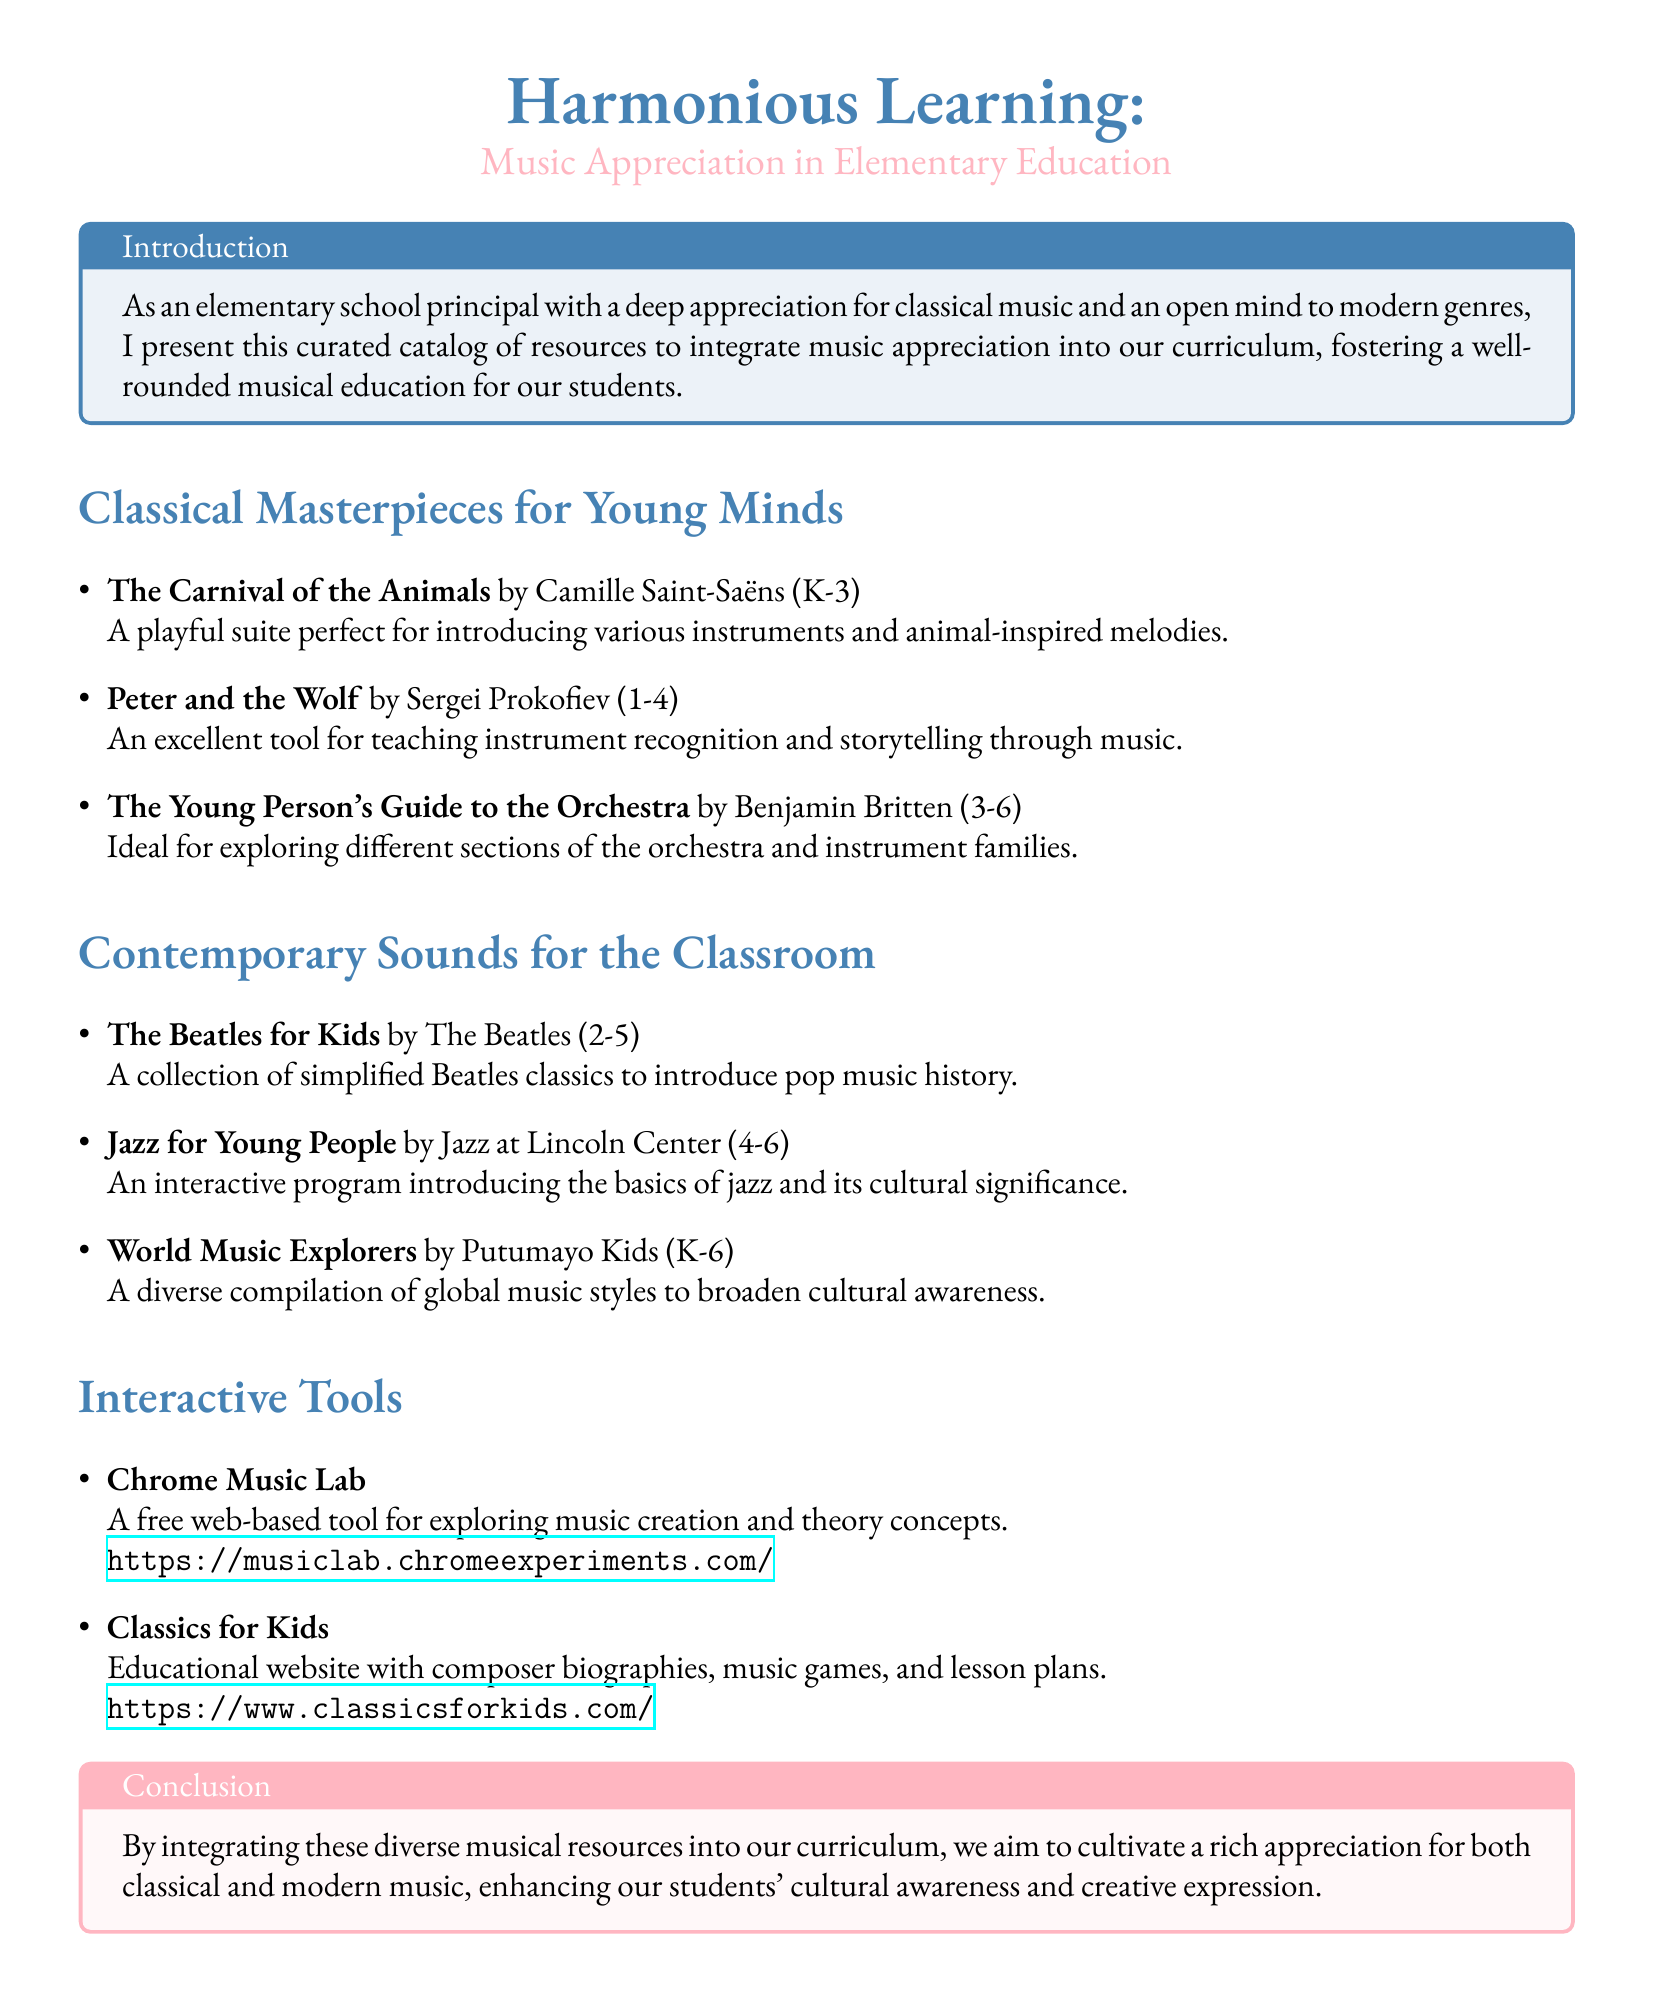What is the title of the catalog? The title of the catalog is prominently displayed at the top of the document, introducing the theme of music appreciation in education.
Answer: Harmonious Learning: Music Appreciation in Elementary Education Who composed "The Carnival of the Animals"? The composer of "The Carnival of the Animals" is mentioned in the section about classical masterpieces, indicating the artist behind the work.
Answer: Camille Saint-Saëns What grade levels does "Peter and the Wolf" target? The document specifies the grade range for "Peter and the Wolf," which is suited for early learners according to the educational resources given.
Answer: 1-4 Which interactive tool helps explore music creation? The document includes a section on interactive tools, stating which resource allows exploration of music theory concepts.
Answer: Chrome Music Lab What type of music does "World Music Explorers" focus on? The resource mentions its aim to broaden cultural awareness through various global music styles.
Answer: Global music styles How many classical pieces are listed in the document? The number of classical pieces listed in the classical masterpieces section is counted for retrieval of specific information.
Answer: 3 Which organization presents "Jazz for Young People"? The document attributes "Jazz for Young People" to a specific organization that provides an interactive program about jazz music.
Answer: Jazz at Lincoln Center What color theme is used for classical music sections? The document uses specific colors to distinguish between classical and modern sections, and the color for classical music is described.
Answer: Classical blue What is a key goal mentioned in the conclusion? The conclusion emphasizes a significant aim of the education initiative relating to diverse music integration.
Answer: Cultivate a rich appreciation 